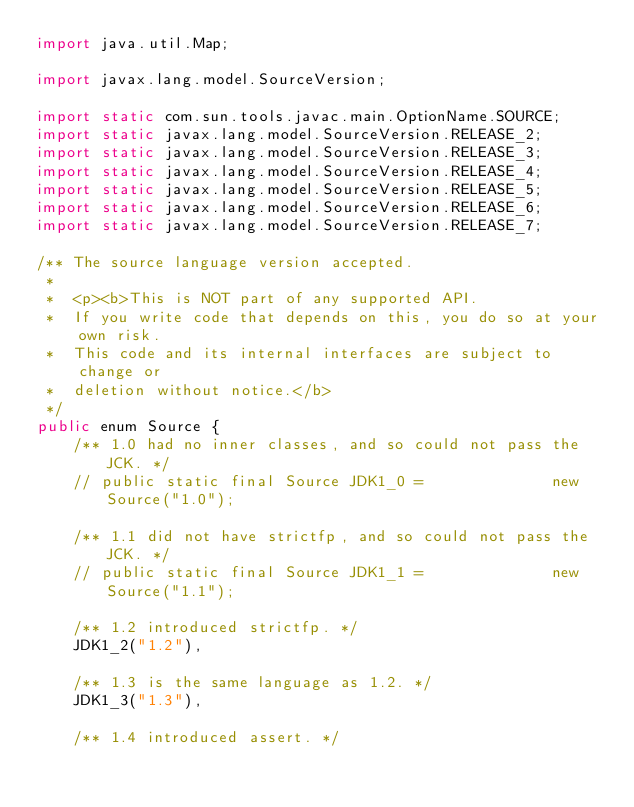<code> <loc_0><loc_0><loc_500><loc_500><_Java_>import java.util.Map;

import javax.lang.model.SourceVersion;

import static com.sun.tools.javac.main.OptionName.SOURCE;
import static javax.lang.model.SourceVersion.RELEASE_2;
import static javax.lang.model.SourceVersion.RELEASE_3;
import static javax.lang.model.SourceVersion.RELEASE_4;
import static javax.lang.model.SourceVersion.RELEASE_5;
import static javax.lang.model.SourceVersion.RELEASE_6;
import static javax.lang.model.SourceVersion.RELEASE_7;

/** The source language version accepted.
 *
 *  <p><b>This is NOT part of any supported API.
 *  If you write code that depends on this, you do so at your own risk.
 *  This code and its internal interfaces are subject to change or
 *  deletion without notice.</b>
 */
public enum Source {
    /** 1.0 had no inner classes, and so could not pass the JCK. */
    // public static final Source JDK1_0 =              new Source("1.0");

    /** 1.1 did not have strictfp, and so could not pass the JCK. */
    // public static final Source JDK1_1 =              new Source("1.1");

    /** 1.2 introduced strictfp. */
    JDK1_2("1.2"),

    /** 1.3 is the same language as 1.2. */
    JDK1_3("1.3"),

    /** 1.4 introduced assert. */</code> 